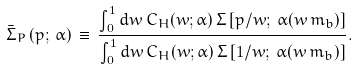Convert formula to latex. <formula><loc_0><loc_0><loc_500><loc_500>\bar { \Sigma } _ { P } \left ( p ; \, \alpha \right ) \, \equiv \, \frac { \int _ { 0 } ^ { 1 } d w \, C _ { H } ( w ; \alpha ) \, \Sigma \left [ p / w ; \, \alpha ( w \, m _ { b } ) \right ] } { \int _ { 0 } ^ { 1 } d w \, C _ { H } ( w ; \alpha ) \, \Sigma \left [ 1 / w ; \, \alpha ( w \, m _ { b } ) \right ] } .</formula> 